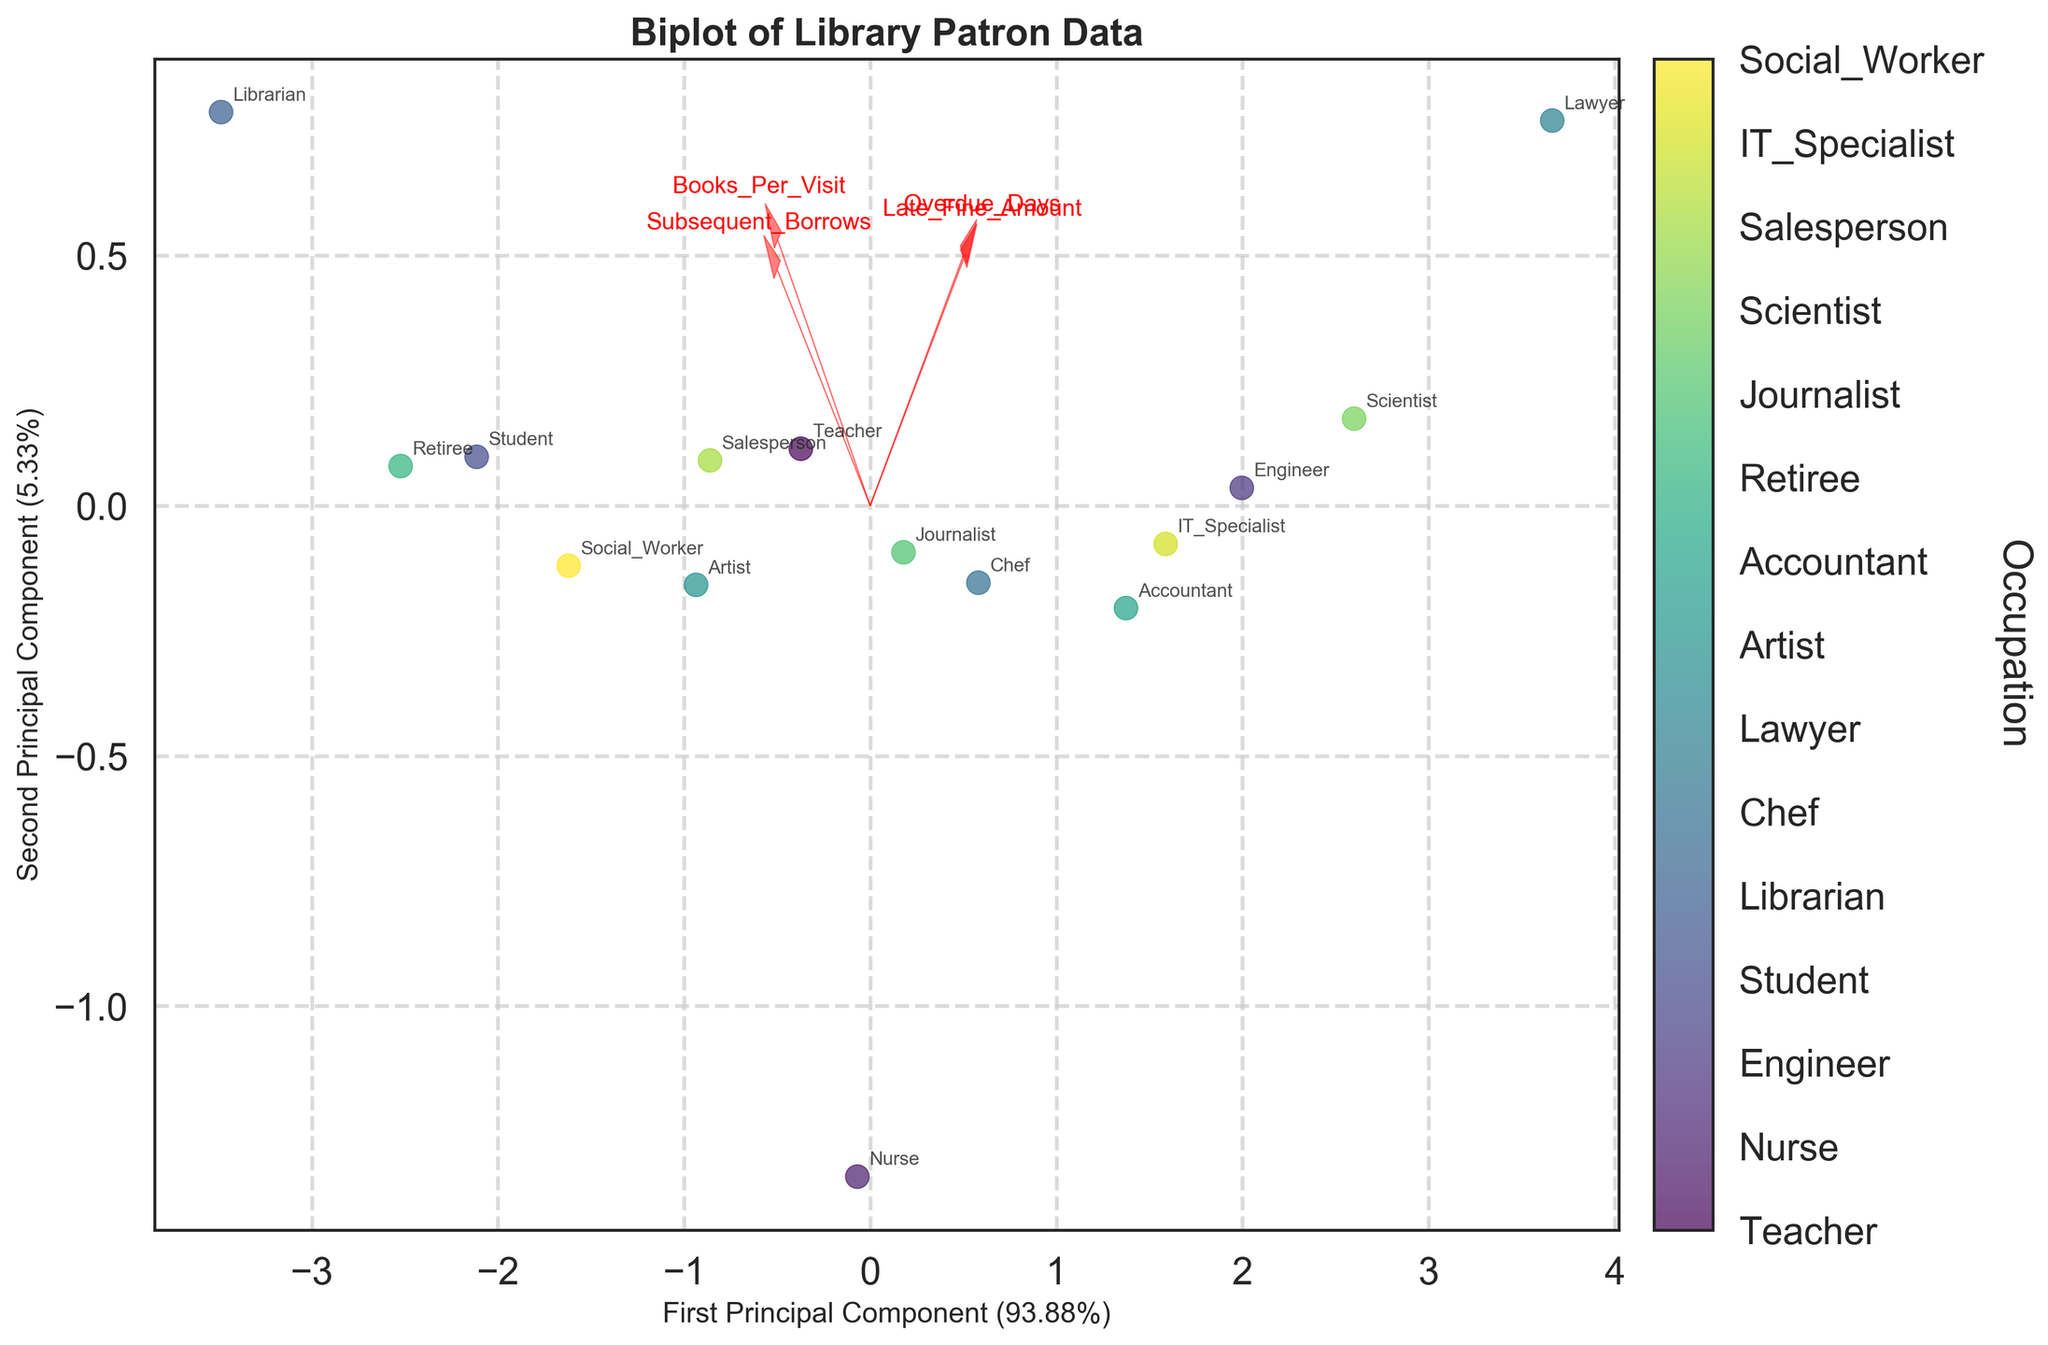What's the title of the plot? The title of the plot is usually located at the top of the figure, giving a concise summary of what the plot represents. In this case, it is labeled "Biplot of Library Patron Data"
Answer: Biplot of Library Patron Data How many features are represented by the arrows? The arrows represent the various features in the dataset. By counting the number of arrows, we can determine how many features are represented.
Answer: Four Which feature vector has the longest arrow or is the most influential? The length of the arrow indicates the influence of the feature on the principal components. The longest arrow on the plot represents the most influential feature.
Answer: Late_Fine_Amount What is the first principal component's explained variance ratio? The first principal component's explained variance ratio is usually indicated on the x-axis label. By reading this label, we find that it accounts for a certain percentage of the variance.
Answer: Approximately 54% Which occupation appears to have the highest subsequent borrows? Occupations can be identified by looking at the labels next to the data points. The one with the highest subsequent borrows can be inferred from the data point farthest in the direction of the Subsequent_Borrows arrow.
Answer: Librarian Which two occupations are closest to each other on the plot? By visually inspecting the plot, we can identify the two data points that are nearest to each other based on their coordinates.
Answer: Nurse and Journalist Which features are positively correlated? Features that are positively correlated will have arrows pointing in roughly the same direction. By examining the positions of the arrows, we can identify such features.
Answer: Books_Per_Visit and Subsequent_Borrows Is there any occupation with zero overdue days present in the plot? If so, which one? Identifying data points with zero overdue days involves looking for labels that are closer to the origin in the direction of the Overdue_Days arrow. By inspecting these points, we identify the occupation.
Answer: Librarian How does Late_Fine_Amount relate to Overdue_Days based on the plot? By observing the direction of the arrows, we can determine the relationship between Late_Fine_Amount and Overdue_Days. Arrows pointing in the same direction suggest a positive correlation, while arrows pointing in opposite directions suggest a negative correlation.
Answer: Positively correlated Which occupation has the least impact on Books_Per_Visit? By observing the length and direction of the Books_Per_Visit arrow, the occupation with the data point furthest away from this arrow's direction would have the least impact on Books_Per_Visit.
Answer: Lawyer 